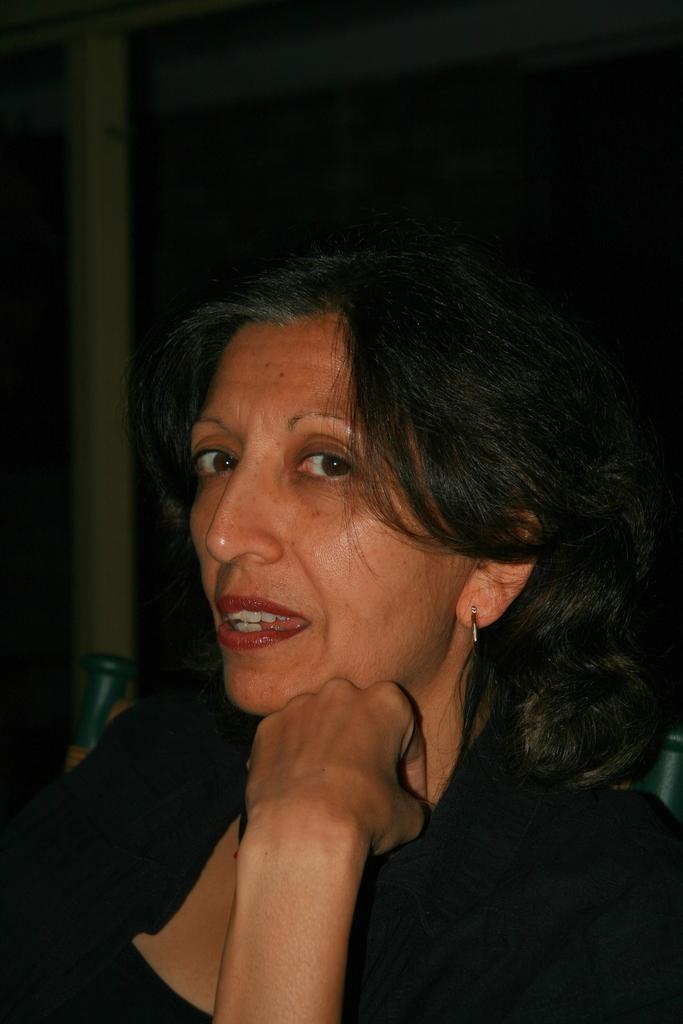How would you summarize this image in a sentence or two? In this picture there is a woman wearing black dress and there are some other objects in the background. 